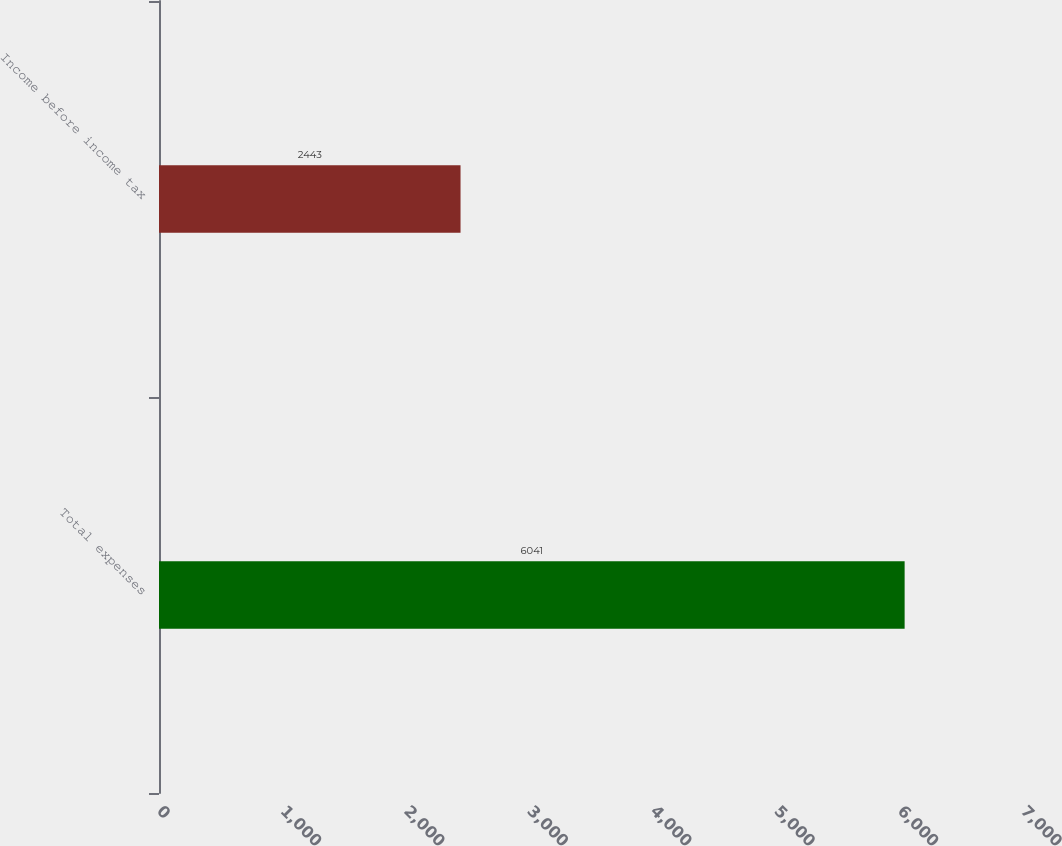Convert chart to OTSL. <chart><loc_0><loc_0><loc_500><loc_500><bar_chart><fcel>Total expenses<fcel>Income before income tax<nl><fcel>6041<fcel>2443<nl></chart> 